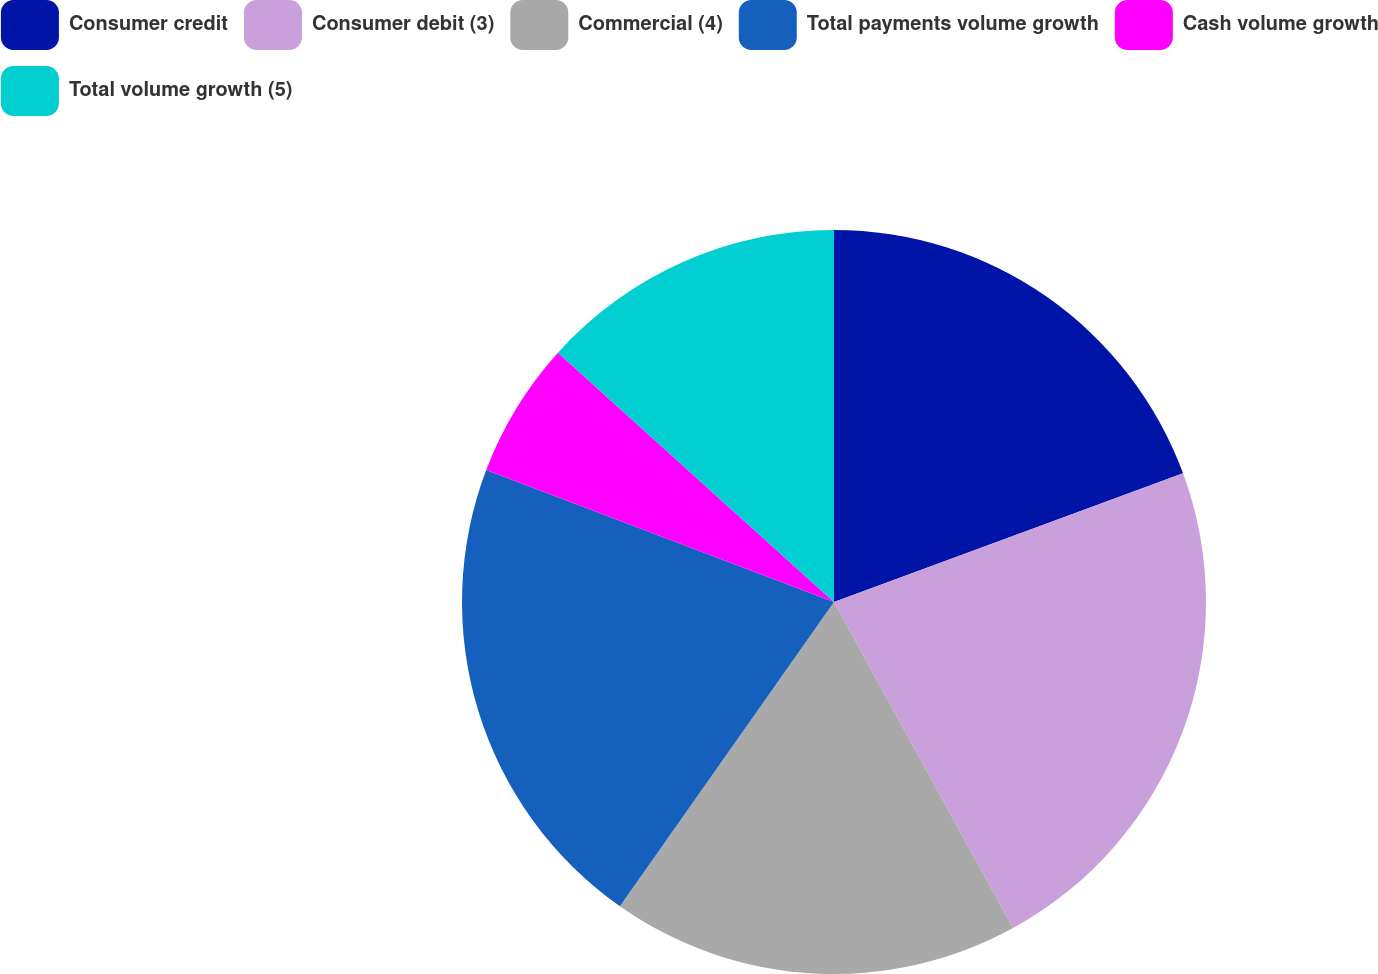Convert chart to OTSL. <chart><loc_0><loc_0><loc_500><loc_500><pie_chart><fcel>Consumer credit<fcel>Consumer debit (3)<fcel>Commercial (4)<fcel>Total payments volume growth<fcel>Cash volume growth<fcel>Total volume growth (5)<nl><fcel>19.38%<fcel>22.63%<fcel>17.75%<fcel>21.01%<fcel>5.92%<fcel>13.31%<nl></chart> 